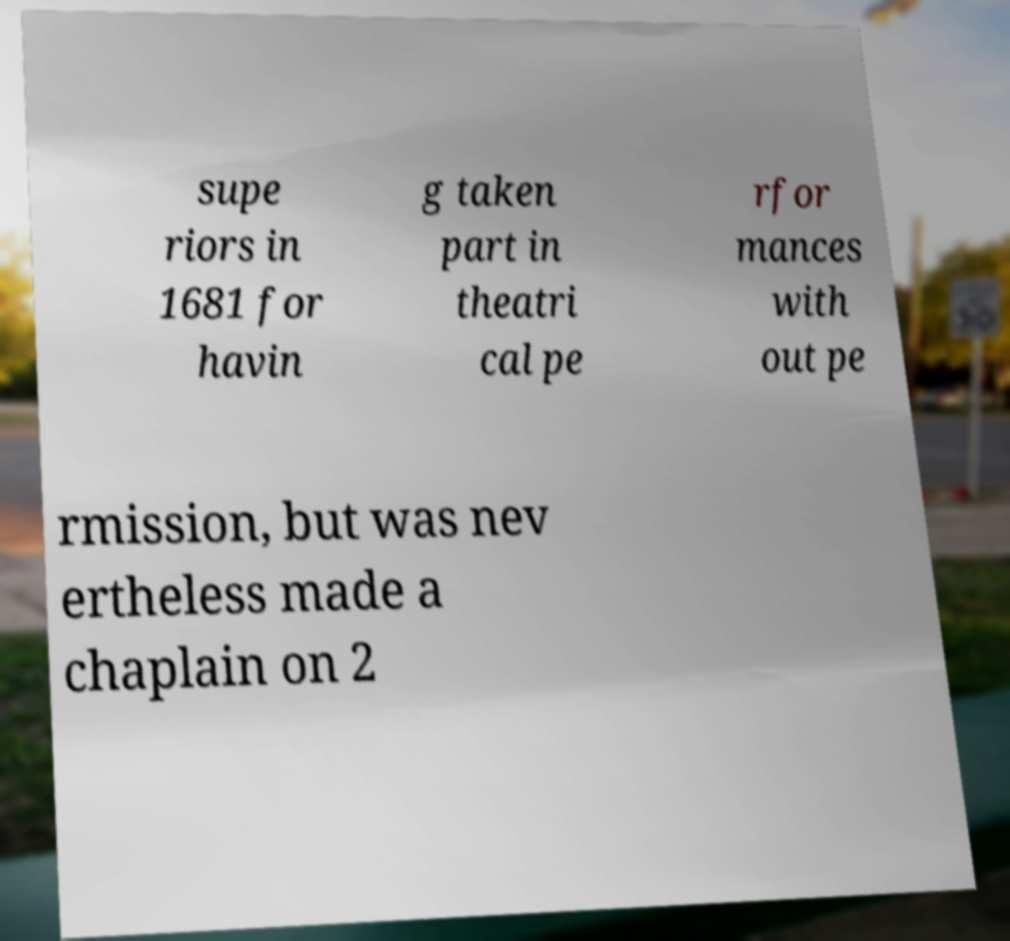There's text embedded in this image that I need extracted. Can you transcribe it verbatim? supe riors in 1681 for havin g taken part in theatri cal pe rfor mances with out pe rmission, but was nev ertheless made a chaplain on 2 